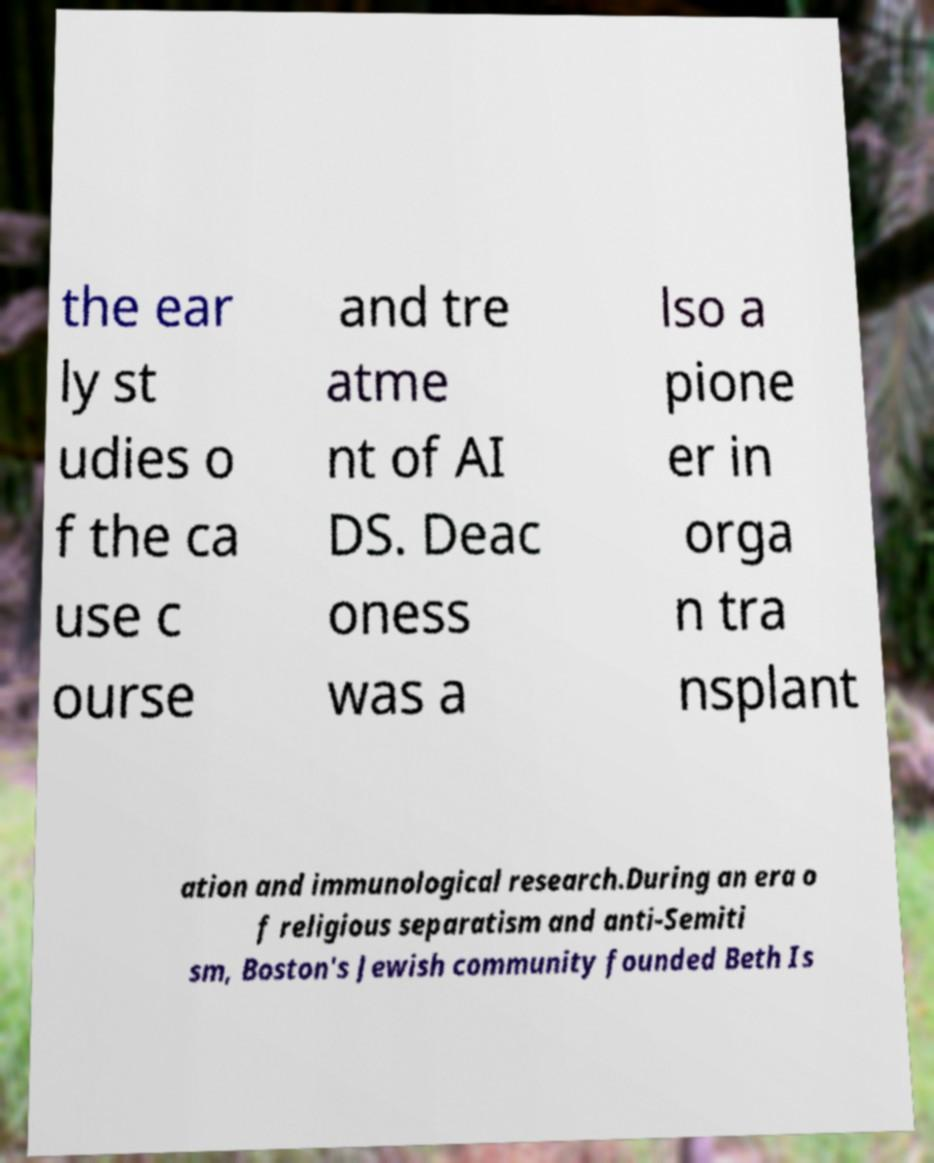Can you accurately transcribe the text from the provided image for me? the ear ly st udies o f the ca use c ourse and tre atme nt of AI DS. Deac oness was a lso a pione er in orga n tra nsplant ation and immunological research.During an era o f religious separatism and anti-Semiti sm, Boston's Jewish community founded Beth Is 